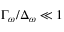<formula> <loc_0><loc_0><loc_500><loc_500>\Gamma _ { \omega } / \Delta _ { \omega } \ll 1</formula> 